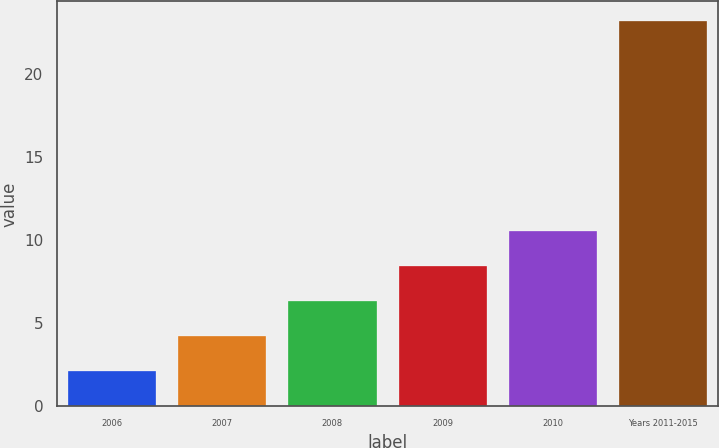Convert chart. <chart><loc_0><loc_0><loc_500><loc_500><bar_chart><fcel>2006<fcel>2007<fcel>2008<fcel>2009<fcel>2010<fcel>Years 2011-2015<nl><fcel>2.1<fcel>4.21<fcel>6.32<fcel>8.43<fcel>10.54<fcel>23.2<nl></chart> 